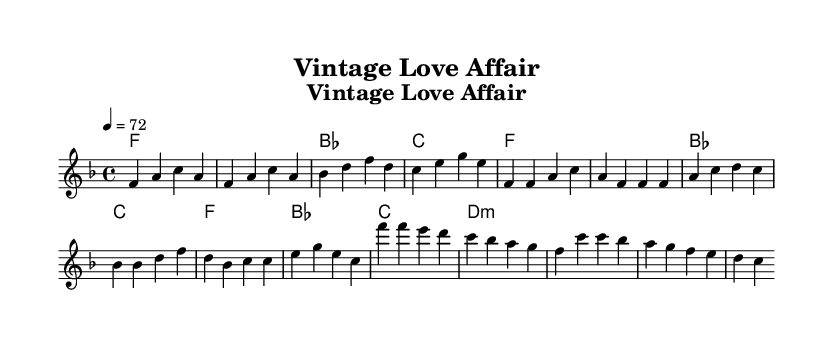What is the key signature of this music? The key signature is F major, which has one flat (B flat). This can be identified from the key signature notation at the beginning of the sheet music.
Answer: F major What is the time signature of the piece? The time signature is 4/4, which is indicated at the beginning of the score. This means there are four beats in each measure, and the quarter note gets one beat.
Answer: 4/4 What is the tempo marking of the piece? The tempo marking indicates a speed of 72 beats per minute, noted at the beginning of the sheet music. This suggests a moderate pace for the performance.
Answer: 72 How many measures are there in the verse section? The verse consists of four distinct measures, as seen in the notation provided under the verse heading. This can be counted by looking at the structure of the melody section.
Answer: 4 Which chord is used in the chorus? The chorus features the D minor chord, which is one of the chords indicated in the chord progression under the chorus heading. This is evident in the chord symbols above the corresponding notes.
Answer: D minor What is the first note of the melody? The first note of the melody is F, it can be found at the start of the music, which corresponds with the melody line's initial tone.
Answer: F How does the melody change in the chorus compared to the verse? The melody in the chorus descends in pitch from F to C, while the verse features a more varied melodic motion. This is analyzed by comparing the sequences from both sections in the sheet music.
Answer: Descends 